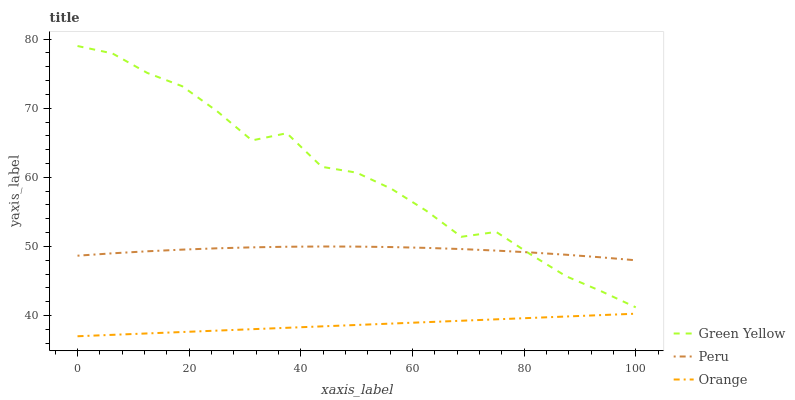Does Orange have the minimum area under the curve?
Answer yes or no. Yes. Does Green Yellow have the maximum area under the curve?
Answer yes or no. Yes. Does Peru have the minimum area under the curve?
Answer yes or no. No. Does Peru have the maximum area under the curve?
Answer yes or no. No. Is Orange the smoothest?
Answer yes or no. Yes. Is Green Yellow the roughest?
Answer yes or no. Yes. Is Peru the smoothest?
Answer yes or no. No. Is Peru the roughest?
Answer yes or no. No. Does Orange have the lowest value?
Answer yes or no. Yes. Does Green Yellow have the lowest value?
Answer yes or no. No. Does Green Yellow have the highest value?
Answer yes or no. Yes. Does Peru have the highest value?
Answer yes or no. No. Is Orange less than Green Yellow?
Answer yes or no. Yes. Is Green Yellow greater than Orange?
Answer yes or no. Yes. Does Peru intersect Green Yellow?
Answer yes or no. Yes. Is Peru less than Green Yellow?
Answer yes or no. No. Is Peru greater than Green Yellow?
Answer yes or no. No. Does Orange intersect Green Yellow?
Answer yes or no. No. 